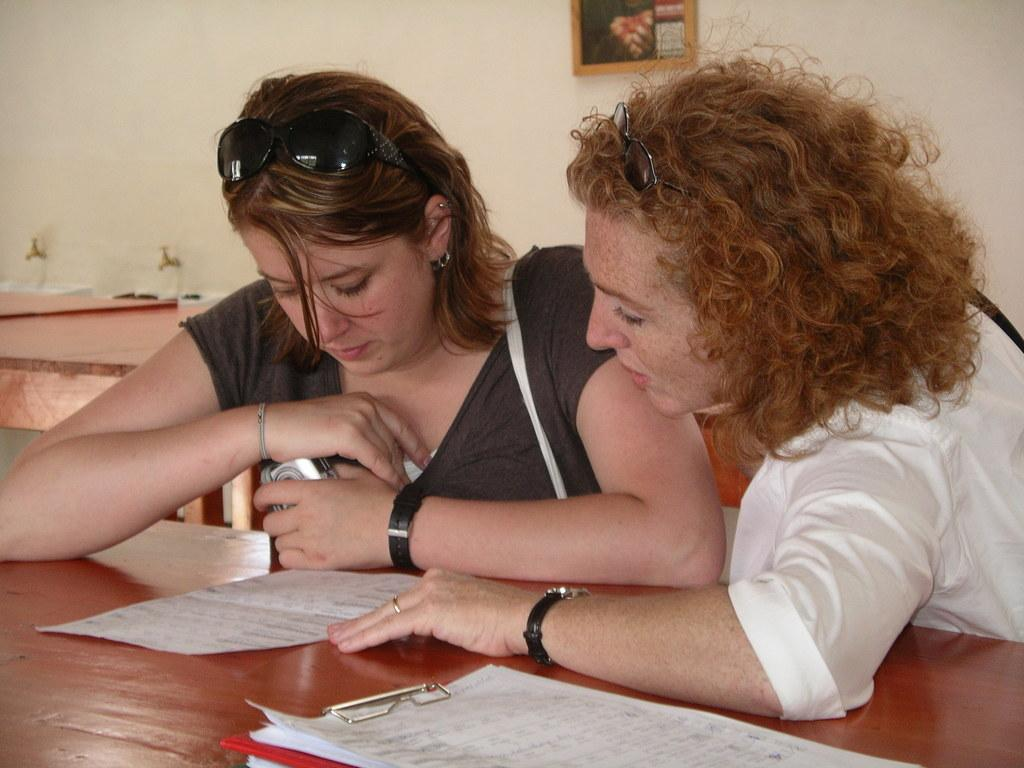How many women are sitting in the image? There are 2 women sitting in the image. What objects related to documentation can be seen in the image? There are papers and a clipboard in the image. What type of decorative item is present in the image? There is a photo frame in the image. What can be used for controlling the flow of water in the image? There are taps in the image. What type of gate is visible in the image? There is no gate present in the image. How many airports can be seen in the image? There is no airport present in the image. 